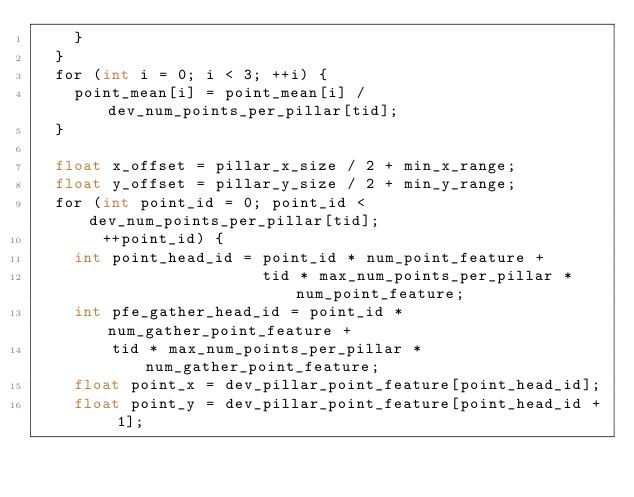<code> <loc_0><loc_0><loc_500><loc_500><_Cuda_>    }
  }
  for (int i = 0; i < 3; ++i) {
    point_mean[i] = point_mean[i] / dev_num_points_per_pillar[tid];
  }

  float x_offset = pillar_x_size / 2 + min_x_range;
  float y_offset = pillar_y_size / 2 + min_y_range;
  for (int point_id = 0; point_id < dev_num_points_per_pillar[tid];
       ++point_id) {
    int point_head_id = point_id * num_point_feature +
                        tid * max_num_points_per_pillar * num_point_feature;
    int pfe_gather_head_id = point_id * num_gather_point_feature +
        tid * max_num_points_per_pillar * num_gather_point_feature;
    float point_x = dev_pillar_point_feature[point_head_id];
    float point_y = dev_pillar_point_feature[point_head_id + 1];</code> 